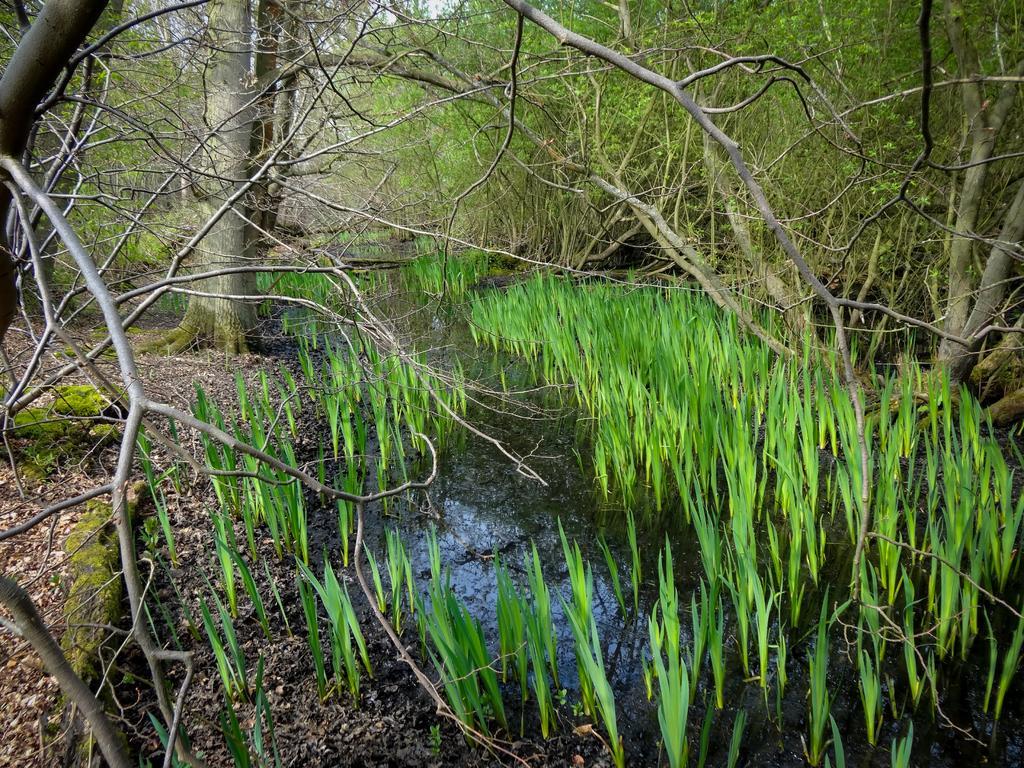How would you summarize this image in a sentence or two? At the bottom of the picture, we see dry leaves, twigs and water. This water might be in the pond. We see the grass in the water. There are trees in the background. 